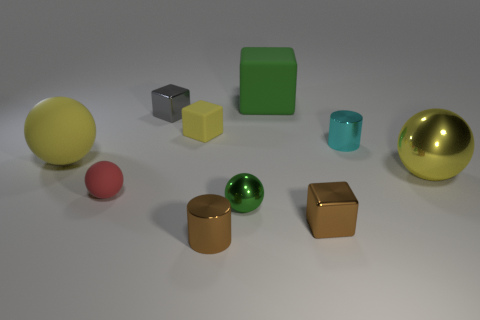Does the small matte block have the same color as the big cube?
Make the answer very short. No. What material is the thing that is both in front of the small red thing and to the right of the large green rubber block?
Make the answer very short. Metal. What is the size of the red object?
Keep it short and to the point. Small. How many small cylinders are on the right side of the big rubber thing that is behind the tiny yellow rubber thing that is behind the yellow matte ball?
Provide a short and direct response. 1. There is a matte object left of the tiny rubber thing in front of the small matte cube; what shape is it?
Give a very brief answer. Sphere. There is a brown metallic thing that is the same shape as the small cyan shiny object; what size is it?
Your answer should be compact. Small. Is there any other thing that has the same size as the cyan cylinder?
Your answer should be compact. Yes. What is the color of the small metal cube that is in front of the small green shiny thing?
Offer a terse response. Brown. The large yellow sphere that is in front of the big sphere that is on the left side of the small ball that is in front of the small rubber ball is made of what material?
Ensure brevity in your answer.  Metal. What is the size of the yellow matte ball left of the tiny red sphere on the left side of the tiny brown cube?
Ensure brevity in your answer.  Large. 